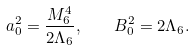<formula> <loc_0><loc_0><loc_500><loc_500>a _ { 0 } ^ { 2 } = \frac { M ^ { 4 } _ { 6 } } { 2 \Lambda _ { 6 } } , \quad B _ { 0 } ^ { 2 } = 2 \Lambda _ { 6 } .</formula> 